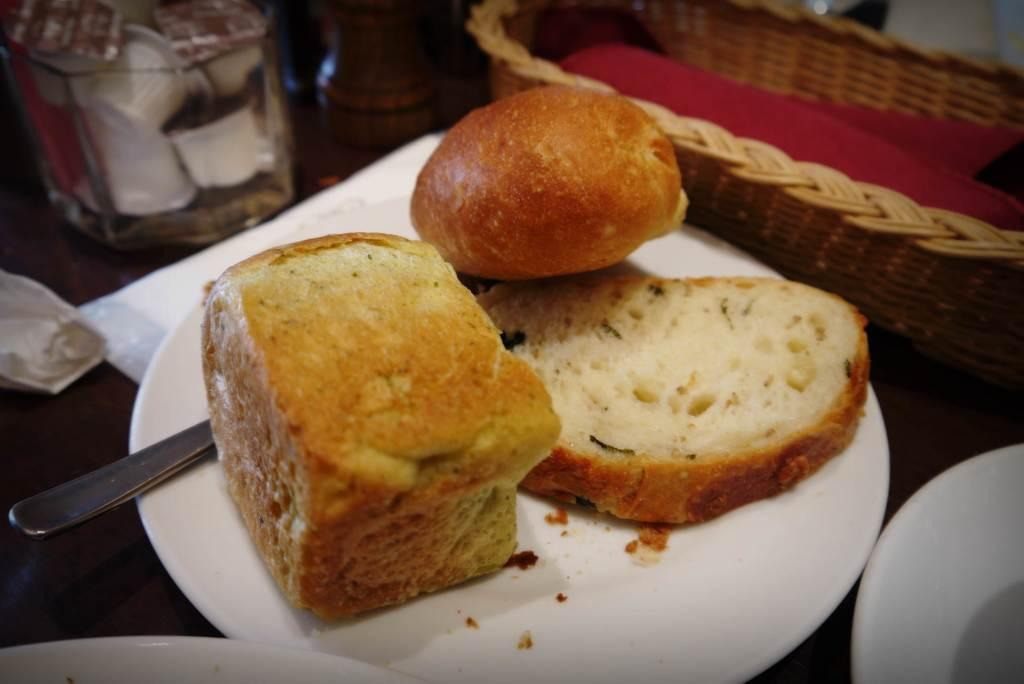What types of food can be seen on the plate in the image? There are different types of breads on a plate in the image. What is located beside the plate? There is a basket beside the plate. How many other plates are there beside the plate with breads? There are two other plates beside the plate with breads. What is located beside the plate with breads and the basket? There is a jar beside the plate. Where are all these items placed? All these items are on a table. What type of rail can be seen in the image? There is no rail present in the image; it features a plate of breads, a basket, two other plates, and a jar on a table. 